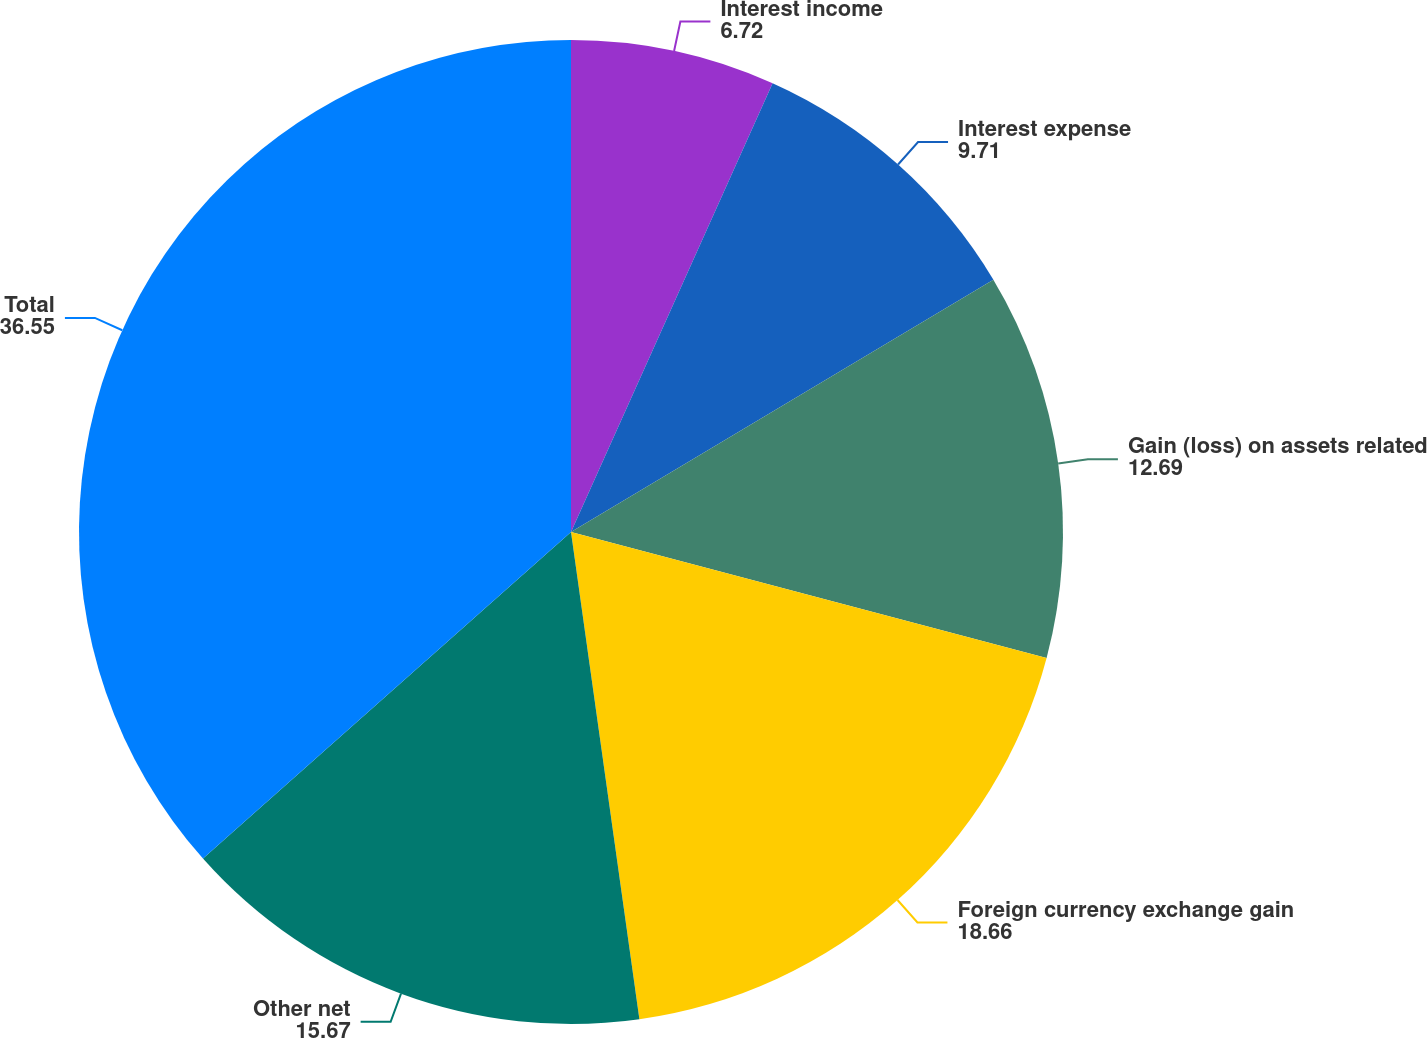Convert chart to OTSL. <chart><loc_0><loc_0><loc_500><loc_500><pie_chart><fcel>Interest income<fcel>Interest expense<fcel>Gain (loss) on assets related<fcel>Foreign currency exchange gain<fcel>Other net<fcel>Total<nl><fcel>6.72%<fcel>9.71%<fcel>12.69%<fcel>18.66%<fcel>15.67%<fcel>36.55%<nl></chart> 